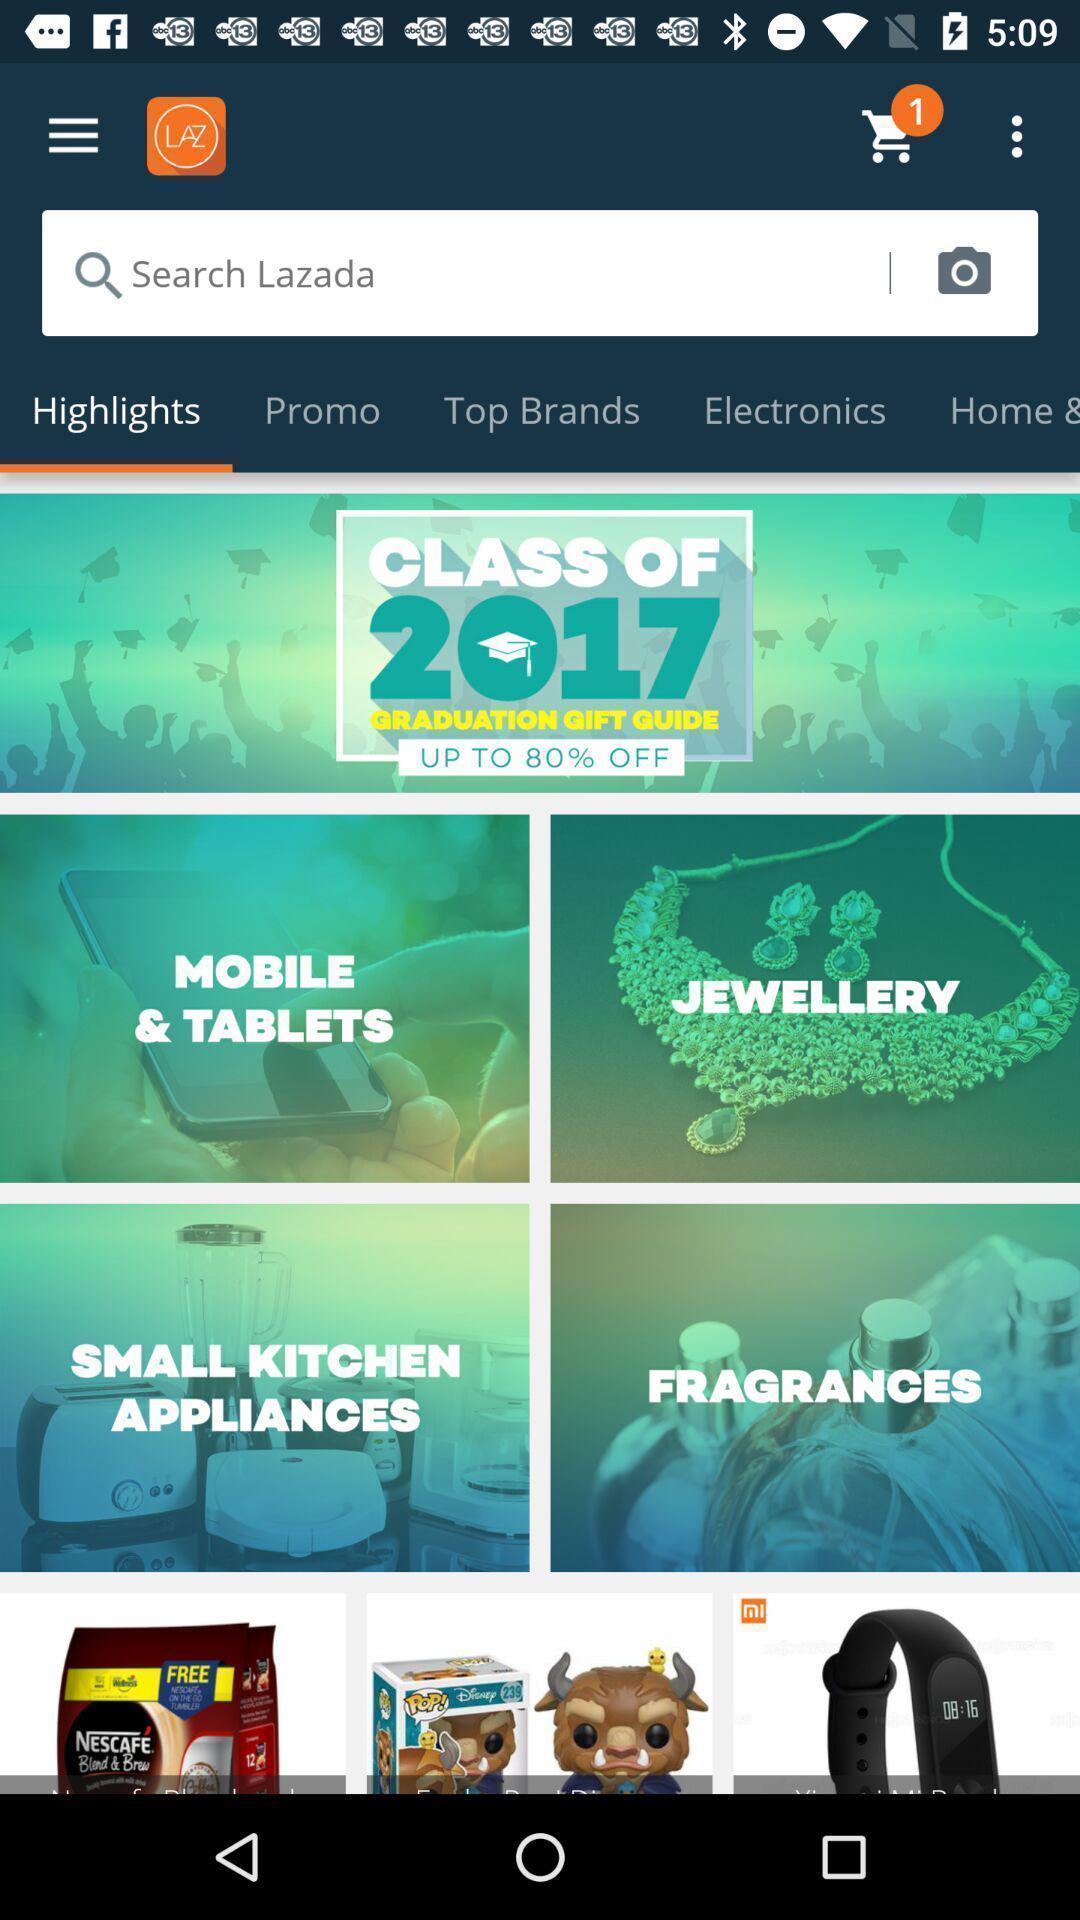Provide a textual representation of this image. Page showing categories in a shopping based app. 